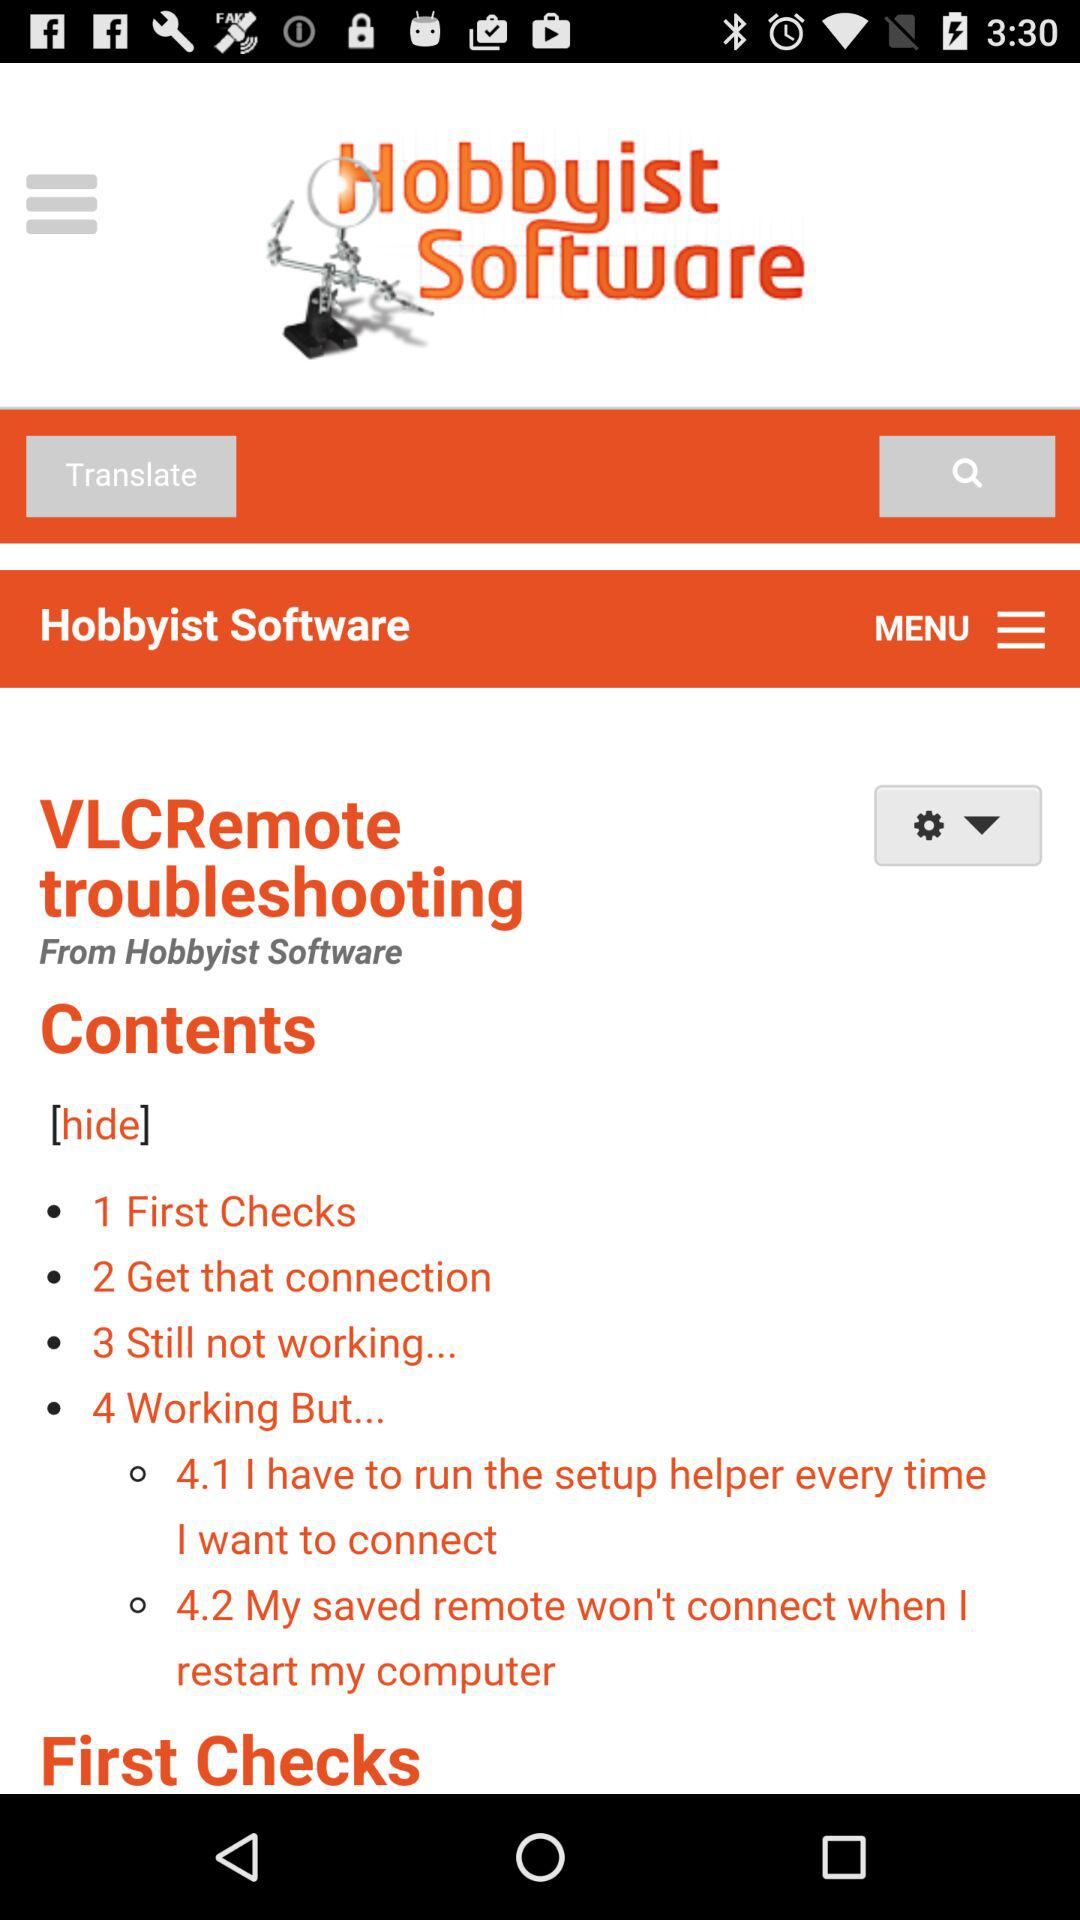What software company has made "VLCRemote troubleshooting"? The software company that has made "VLCRemote troubleshooting" is "Hobbyist Software". 